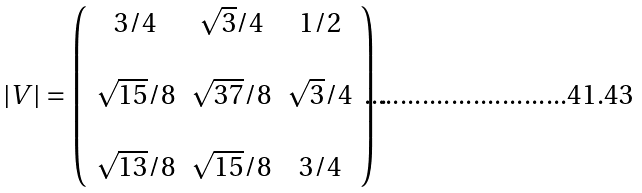<formula> <loc_0><loc_0><loc_500><loc_500>| V | = \left ( \begin{array} { c c c } 3 / 4 & \sqrt { 3 } / 4 & 1 / 2 \\ \\ \sqrt { 1 5 } / 8 & \sqrt { 3 7 } / 8 & \sqrt { 3 } / 4 \\ \\ \sqrt { 1 3 } / 8 & \sqrt { 1 5 } / 8 & 3 / 4 \end{array} \right ) .</formula> 